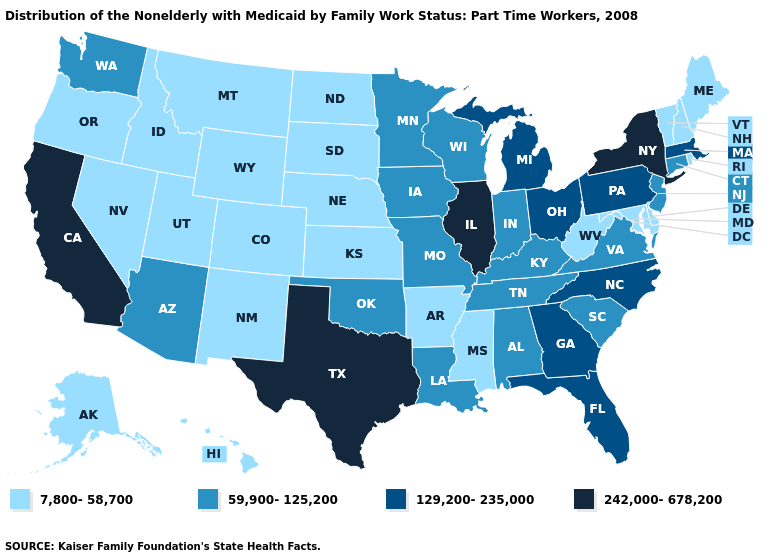Among the states that border New Mexico , which have the highest value?
Answer briefly. Texas. Does the first symbol in the legend represent the smallest category?
Short answer required. Yes. Name the states that have a value in the range 242,000-678,200?
Keep it brief. California, Illinois, New York, Texas. Name the states that have a value in the range 242,000-678,200?
Be succinct. California, Illinois, New York, Texas. Which states have the lowest value in the USA?
Keep it brief. Alaska, Arkansas, Colorado, Delaware, Hawaii, Idaho, Kansas, Maine, Maryland, Mississippi, Montana, Nebraska, Nevada, New Hampshire, New Mexico, North Dakota, Oregon, Rhode Island, South Dakota, Utah, Vermont, West Virginia, Wyoming. How many symbols are there in the legend?
Keep it brief. 4. Which states have the lowest value in the MidWest?
Answer briefly. Kansas, Nebraska, North Dakota, South Dakota. What is the value of California?
Short answer required. 242,000-678,200. Does South Dakota have the highest value in the USA?
Answer briefly. No. What is the value of Washington?
Keep it brief. 59,900-125,200. Among the states that border Connecticut , does Rhode Island have the lowest value?
Be succinct. Yes. Does Connecticut have a higher value than Utah?
Keep it brief. Yes. Name the states that have a value in the range 242,000-678,200?
Concise answer only. California, Illinois, New York, Texas. Does the first symbol in the legend represent the smallest category?
Answer briefly. Yes. 